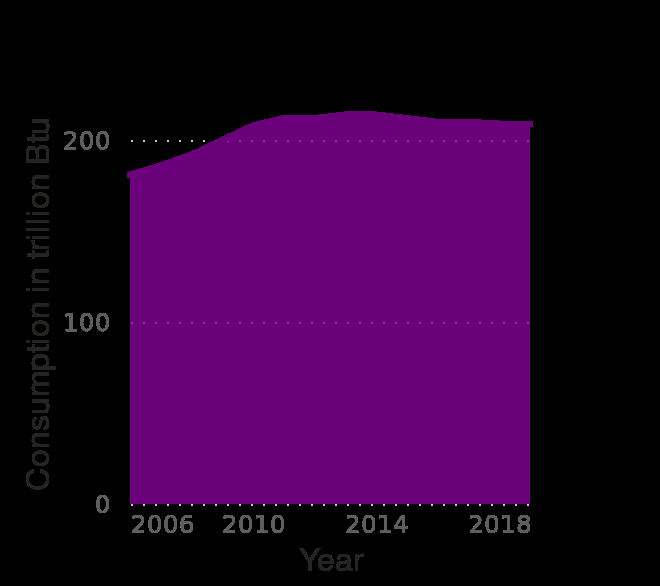<image>
Was there a continuous rise in geothermal energy usage? No, there was a slow increase, but then the usage levelled off. What was the trend in geothermal energy usage after 2009? After 2009, the geothermal energy usage remained stable without any significant increase or decrease. Offer a thorough analysis of the image. There was a slow increase in geothermal energy take u until approximately 2009 where the usage levelled off. 